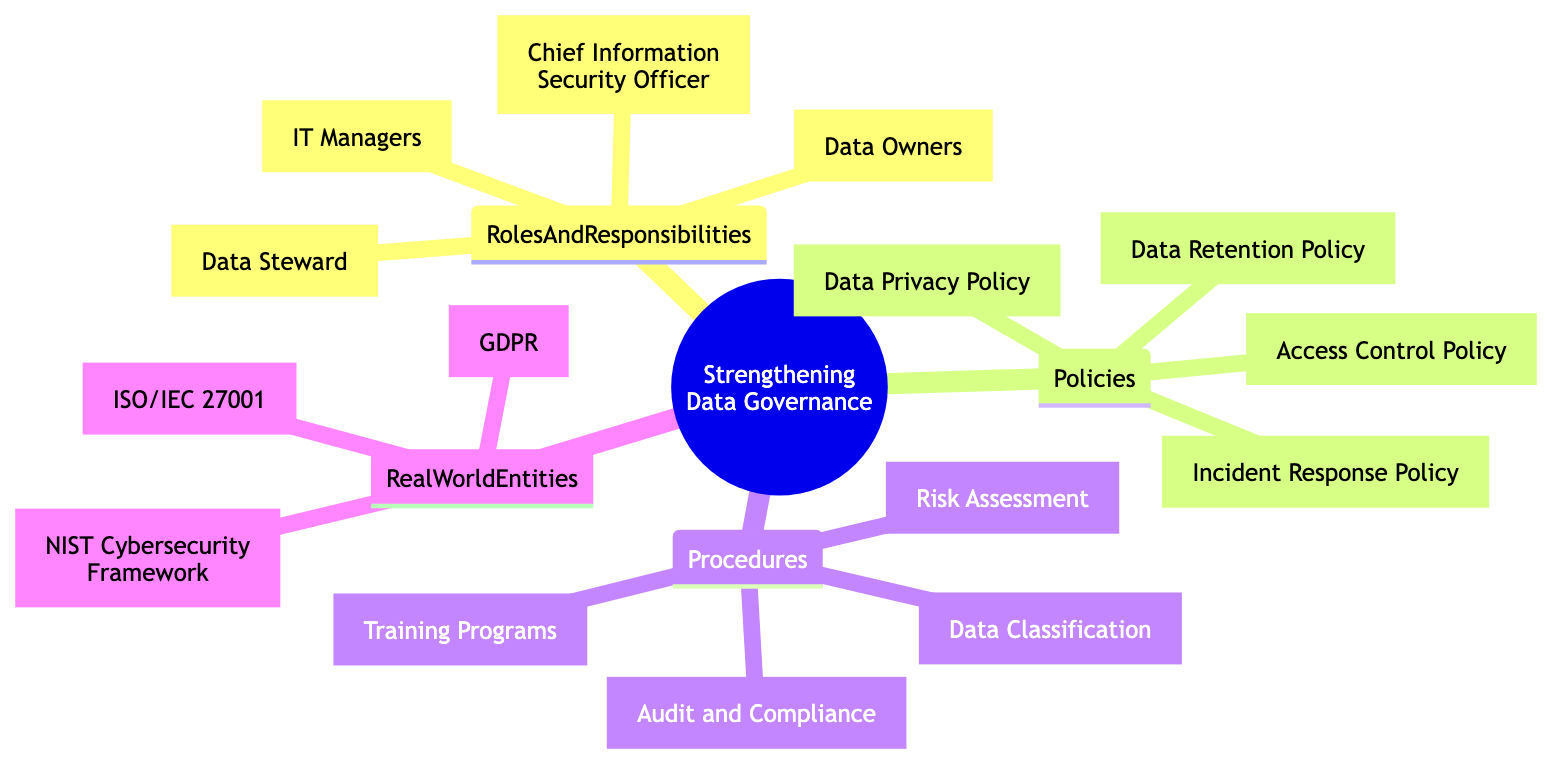What are the roles listed under Strengthening Data Governance? The diagram has a section labeled "RolesAndResponsibilities" that includes CISO, Data Steward, Data Owners, and IT Managers. These titles represent the key roles in data governance.
Answer: CISO, Data Steward, Data Owners, IT Managers How many policies are mentioned in the diagram? By counting the items listed under "Policies," we find four specific policies: Data Privacy Policy, Access Control Policy, Data Retention Policy, and Incident Response Policy.
Answer: 4 Which policy outlines personal data collection and protection? The diagram illustrates that the Data Privacy Policy is specifically tasked with detailing how personal data is collected, processed, and protected.
Answer: Data Privacy Policy Who is responsible for data quality and integrity? The Data Steward is identified in the "RolesAndResponsibilities" section of the diagram as the role that manages and ensures data quality and integrity.
Answer: Data Steward What procedure involves categorizing data? According to the "Procedures" section of the diagram, the Data Classification procedure is specifically mentioned as the method for categorizing data based on its sensitivity and importance.
Answer: Data Classification What is the purpose of the Risk Assessment procedure? The diagram states that the Risk Assessment procedure is regularly conducted to identify and mitigate potential data risks, indicating its goal of risk management in data governance.
Answer: Identify and mitigate data risks Which framework is mentioned in the Real World Entities? The diagram lists the NIST Cybersecurity Framework under the "RealWorldEntities" section, highlighting it as one of the guidelines for improving cybersecurity relevant to data governance.
Answer: NIST Cybersecurity Framework How many entities are listed under Real World Entities? The "RealWorldEntities" section comprises three entities: ISO27001, GDPR, and NIST Cybersecurity Framework. Thus, when counted, there are three entities present.
Answer: 3 What does the Incident Response Policy detail? Within the policies outlined in the diagram, the Incident Response Policy specifically describes the protocols to be followed when responding to data breaches and other related incidents.
Answer: Protocols for responding to incidents 